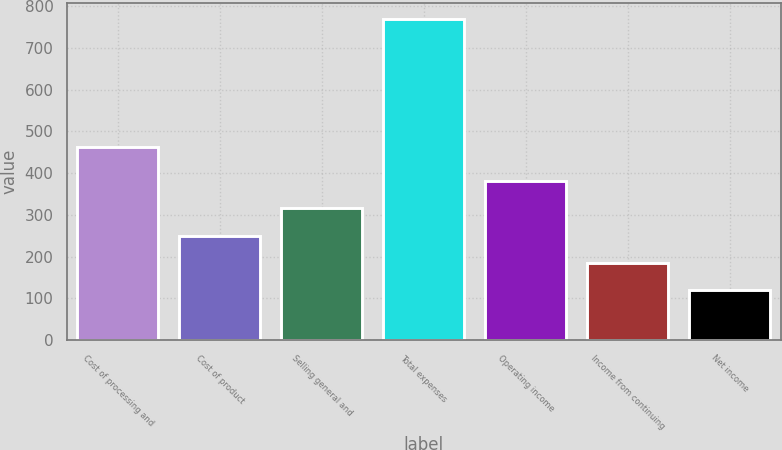<chart> <loc_0><loc_0><loc_500><loc_500><bar_chart><fcel>Cost of processing and<fcel>Cost of product<fcel>Selling general and<fcel>Total expenses<fcel>Operating income<fcel>Income from continuing<fcel>Net income<nl><fcel>462<fcel>250.8<fcel>315.7<fcel>770<fcel>380.6<fcel>185.9<fcel>121<nl></chart> 